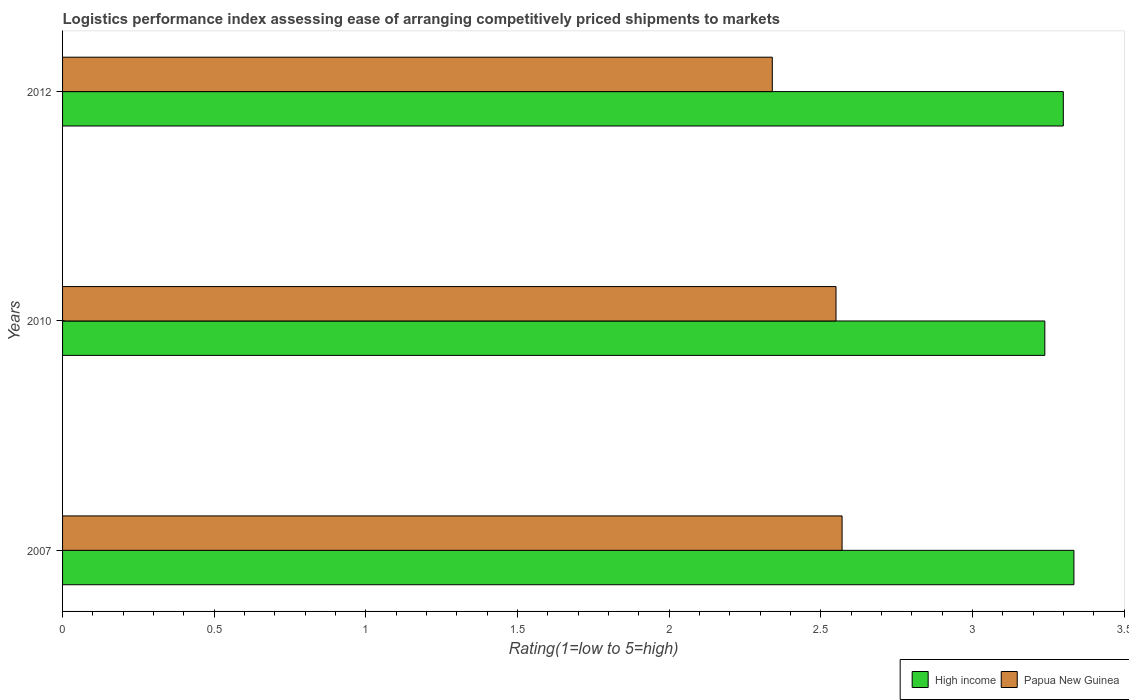How many different coloured bars are there?
Your answer should be very brief. 2. Are the number of bars per tick equal to the number of legend labels?
Provide a short and direct response. Yes. How many bars are there on the 1st tick from the bottom?
Ensure brevity in your answer.  2. What is the label of the 3rd group of bars from the top?
Provide a succinct answer. 2007. What is the Logistic performance index in Papua New Guinea in 2012?
Offer a very short reply. 2.34. Across all years, what is the maximum Logistic performance index in High income?
Offer a very short reply. 3.33. Across all years, what is the minimum Logistic performance index in High income?
Your response must be concise. 3.24. In which year was the Logistic performance index in Papua New Guinea maximum?
Give a very brief answer. 2007. In which year was the Logistic performance index in High income minimum?
Keep it short and to the point. 2010. What is the total Logistic performance index in Papua New Guinea in the graph?
Offer a very short reply. 7.46. What is the difference between the Logistic performance index in High income in 2007 and that in 2010?
Your response must be concise. 0.1. What is the difference between the Logistic performance index in Papua New Guinea in 2010 and the Logistic performance index in High income in 2012?
Provide a short and direct response. -0.75. What is the average Logistic performance index in Papua New Guinea per year?
Make the answer very short. 2.49. In the year 2007, what is the difference between the Logistic performance index in Papua New Guinea and Logistic performance index in High income?
Your answer should be compact. -0.76. In how many years, is the Logistic performance index in Papua New Guinea greater than 3 ?
Ensure brevity in your answer.  0. What is the ratio of the Logistic performance index in High income in 2007 to that in 2012?
Provide a succinct answer. 1.01. What is the difference between the highest and the second highest Logistic performance index in High income?
Keep it short and to the point. 0.03. What is the difference between the highest and the lowest Logistic performance index in High income?
Provide a succinct answer. 0.1. Is the sum of the Logistic performance index in High income in 2010 and 2012 greater than the maximum Logistic performance index in Papua New Guinea across all years?
Your answer should be very brief. Yes. What does the 2nd bar from the top in 2007 represents?
Your answer should be compact. High income. What does the 2nd bar from the bottom in 2007 represents?
Give a very brief answer. Papua New Guinea. How many bars are there?
Give a very brief answer. 6. Are the values on the major ticks of X-axis written in scientific E-notation?
Keep it short and to the point. No. Does the graph contain any zero values?
Your response must be concise. No. Does the graph contain grids?
Your response must be concise. No. Where does the legend appear in the graph?
Give a very brief answer. Bottom right. What is the title of the graph?
Give a very brief answer. Logistics performance index assessing ease of arranging competitively priced shipments to markets. Does "Middle income" appear as one of the legend labels in the graph?
Provide a succinct answer. No. What is the label or title of the X-axis?
Offer a very short reply. Rating(1=low to 5=high). What is the Rating(1=low to 5=high) of High income in 2007?
Ensure brevity in your answer.  3.33. What is the Rating(1=low to 5=high) of Papua New Guinea in 2007?
Offer a very short reply. 2.57. What is the Rating(1=low to 5=high) in High income in 2010?
Ensure brevity in your answer.  3.24. What is the Rating(1=low to 5=high) in Papua New Guinea in 2010?
Offer a very short reply. 2.55. What is the Rating(1=low to 5=high) in High income in 2012?
Your answer should be compact. 3.3. What is the Rating(1=low to 5=high) of Papua New Guinea in 2012?
Provide a succinct answer. 2.34. Across all years, what is the maximum Rating(1=low to 5=high) of High income?
Your answer should be very brief. 3.33. Across all years, what is the maximum Rating(1=low to 5=high) of Papua New Guinea?
Give a very brief answer. 2.57. Across all years, what is the minimum Rating(1=low to 5=high) in High income?
Your answer should be very brief. 3.24. Across all years, what is the minimum Rating(1=low to 5=high) in Papua New Guinea?
Your answer should be very brief. 2.34. What is the total Rating(1=low to 5=high) in High income in the graph?
Your answer should be compact. 9.87. What is the total Rating(1=low to 5=high) in Papua New Guinea in the graph?
Offer a terse response. 7.46. What is the difference between the Rating(1=low to 5=high) in High income in 2007 and that in 2010?
Give a very brief answer. 0.1. What is the difference between the Rating(1=low to 5=high) in High income in 2007 and that in 2012?
Offer a terse response. 0.04. What is the difference between the Rating(1=low to 5=high) in Papua New Guinea in 2007 and that in 2012?
Keep it short and to the point. 0.23. What is the difference between the Rating(1=low to 5=high) in High income in 2010 and that in 2012?
Your response must be concise. -0.06. What is the difference between the Rating(1=low to 5=high) in Papua New Guinea in 2010 and that in 2012?
Offer a very short reply. 0.21. What is the difference between the Rating(1=low to 5=high) of High income in 2007 and the Rating(1=low to 5=high) of Papua New Guinea in 2010?
Offer a terse response. 0.78. What is the difference between the Rating(1=low to 5=high) of High income in 2010 and the Rating(1=low to 5=high) of Papua New Guinea in 2012?
Keep it short and to the point. 0.9. What is the average Rating(1=low to 5=high) of High income per year?
Provide a succinct answer. 3.29. What is the average Rating(1=low to 5=high) in Papua New Guinea per year?
Offer a terse response. 2.49. In the year 2007, what is the difference between the Rating(1=low to 5=high) of High income and Rating(1=low to 5=high) of Papua New Guinea?
Make the answer very short. 0.76. In the year 2010, what is the difference between the Rating(1=low to 5=high) in High income and Rating(1=low to 5=high) in Papua New Guinea?
Offer a terse response. 0.69. In the year 2012, what is the difference between the Rating(1=low to 5=high) of High income and Rating(1=low to 5=high) of Papua New Guinea?
Give a very brief answer. 0.96. What is the ratio of the Rating(1=low to 5=high) in High income in 2007 to that in 2010?
Your answer should be compact. 1.03. What is the ratio of the Rating(1=low to 5=high) of High income in 2007 to that in 2012?
Make the answer very short. 1.01. What is the ratio of the Rating(1=low to 5=high) of Papua New Guinea in 2007 to that in 2012?
Keep it short and to the point. 1.1. What is the ratio of the Rating(1=low to 5=high) of High income in 2010 to that in 2012?
Your answer should be compact. 0.98. What is the ratio of the Rating(1=low to 5=high) in Papua New Guinea in 2010 to that in 2012?
Your response must be concise. 1.09. What is the difference between the highest and the second highest Rating(1=low to 5=high) in High income?
Make the answer very short. 0.04. What is the difference between the highest and the lowest Rating(1=low to 5=high) of High income?
Your answer should be very brief. 0.1. What is the difference between the highest and the lowest Rating(1=low to 5=high) in Papua New Guinea?
Provide a succinct answer. 0.23. 